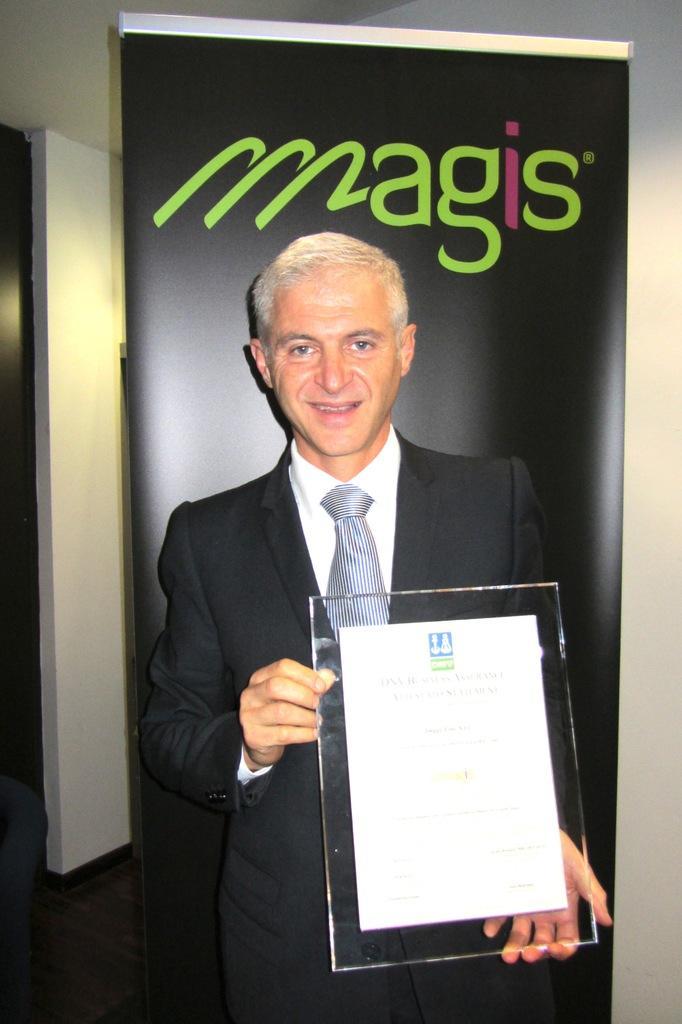Could you give a brief overview of what you see in this image? This is the picture of a room. In this image there is a person standing and smiling and he is holding the frame. On the left side of the image there is a door. At the back there is a hoarding and there is a text on the hoarding. 